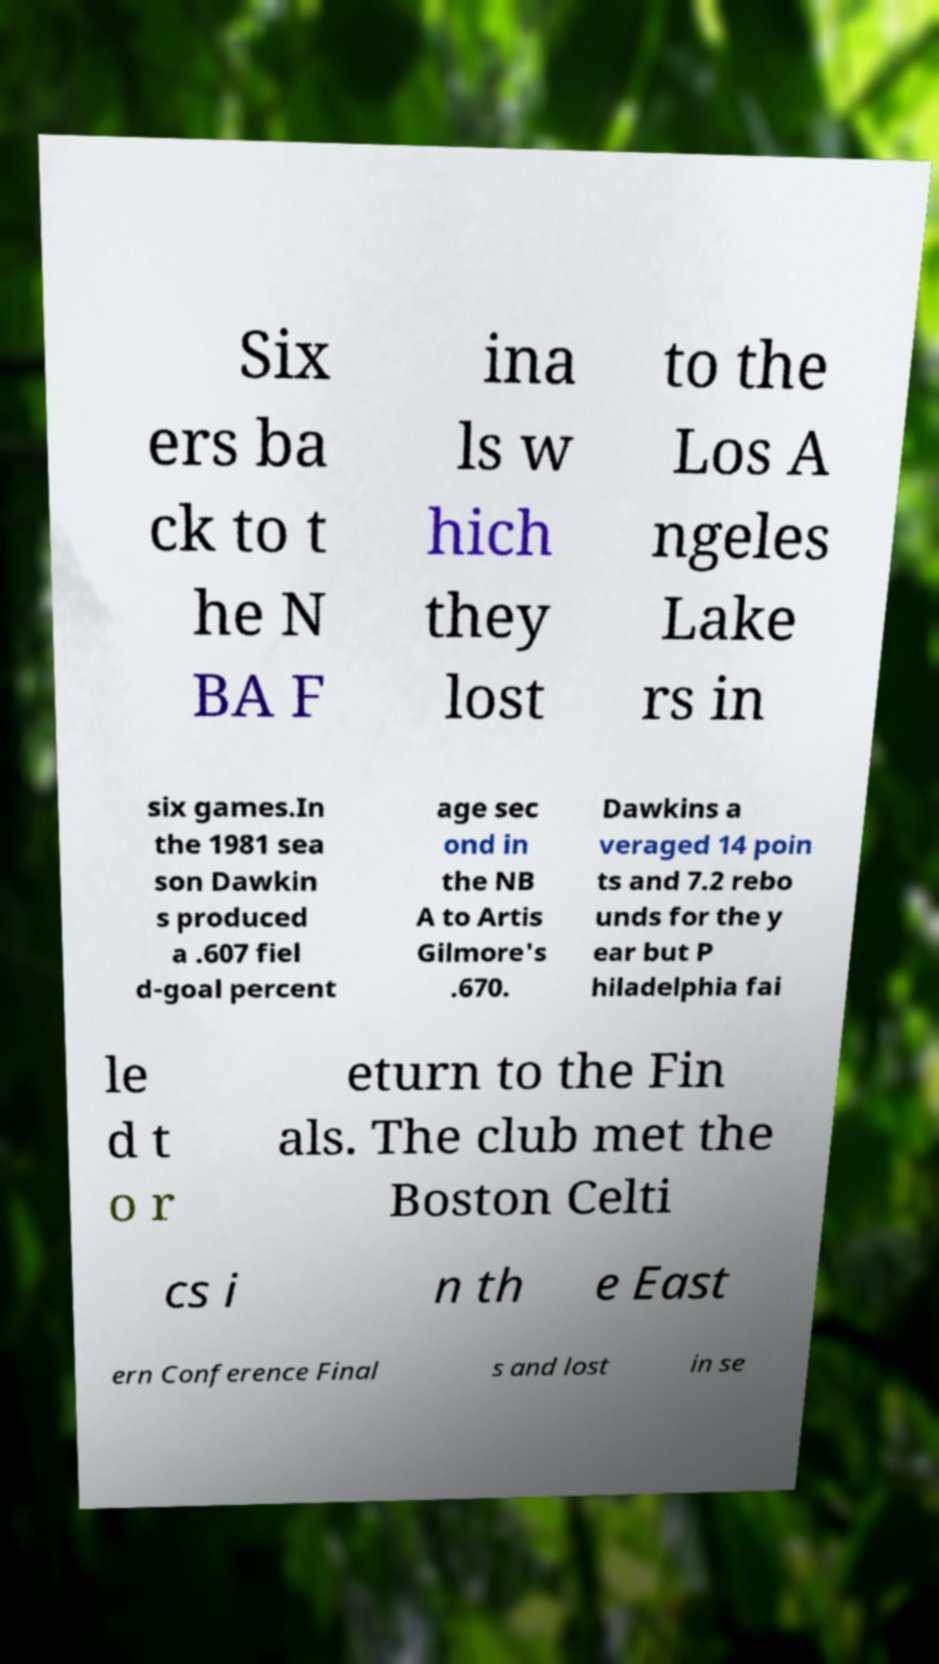What messages or text are displayed in this image? I need them in a readable, typed format. Six ers ba ck to t he N BA F ina ls w hich they lost to the Los A ngeles Lake rs in six games.In the 1981 sea son Dawkin s produced a .607 fiel d-goal percent age sec ond in the NB A to Artis Gilmore's .670. Dawkins a veraged 14 poin ts and 7.2 rebo unds for the y ear but P hiladelphia fai le d t o r eturn to the Fin als. The club met the Boston Celti cs i n th e East ern Conference Final s and lost in se 